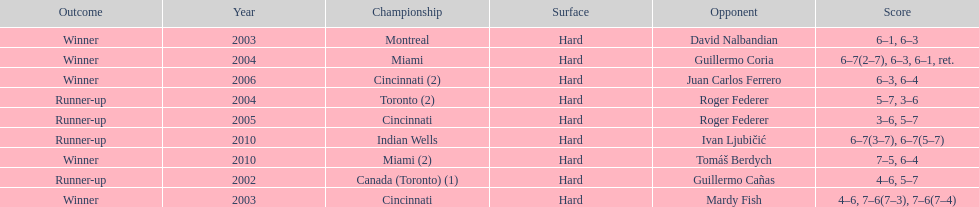How many championships occurred in toronto or montreal? 3. 